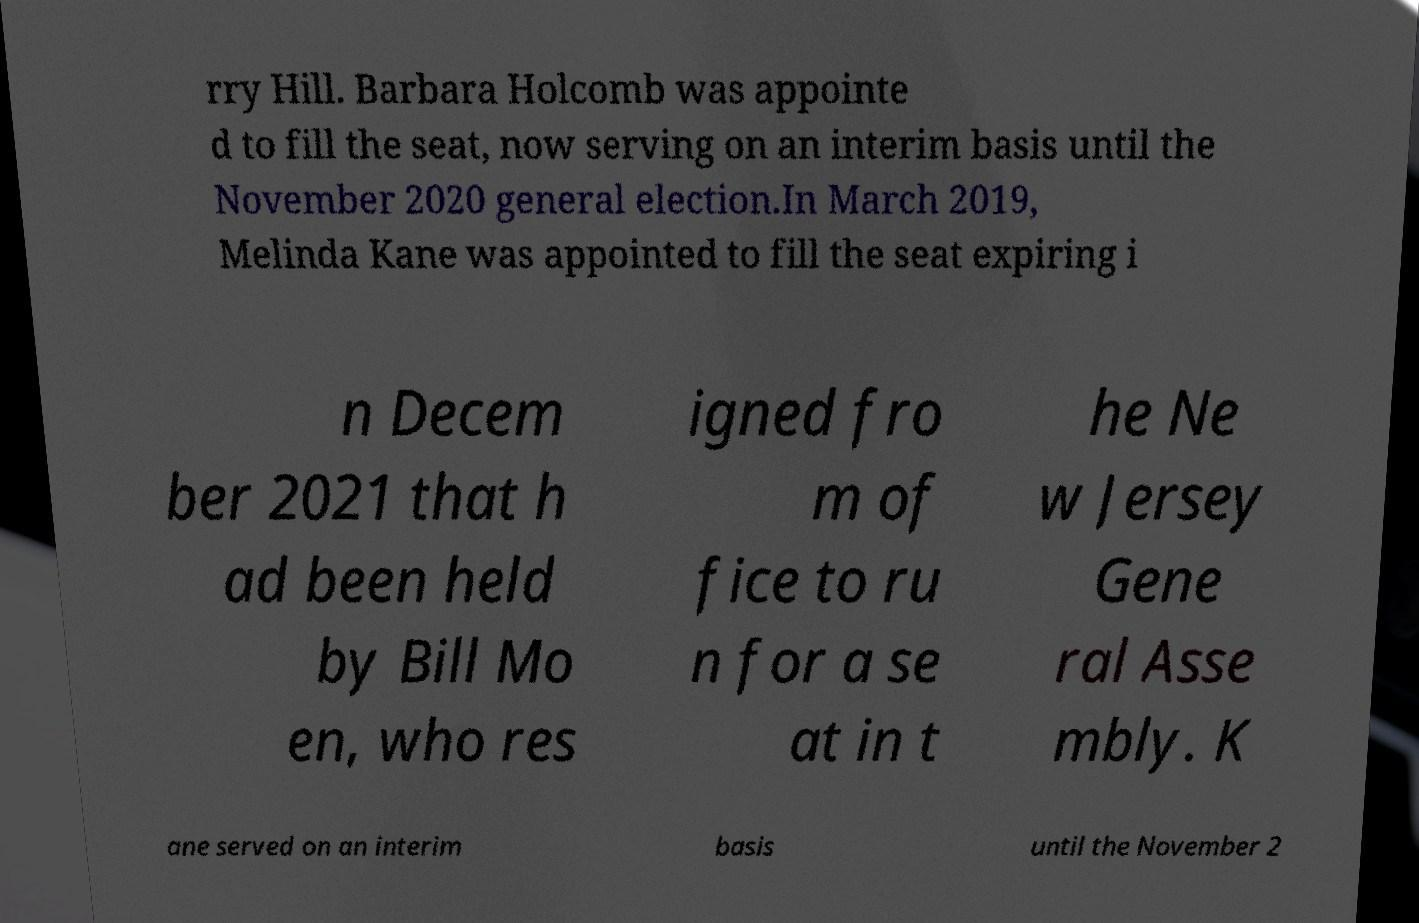Please identify and transcribe the text found in this image. rry Hill. Barbara Holcomb was appointe d to fill the seat, now serving on an interim basis until the November 2020 general election.In March 2019, Melinda Kane was appointed to fill the seat expiring i n Decem ber 2021 that h ad been held by Bill Mo en, who res igned fro m of fice to ru n for a se at in t he Ne w Jersey Gene ral Asse mbly. K ane served on an interim basis until the November 2 